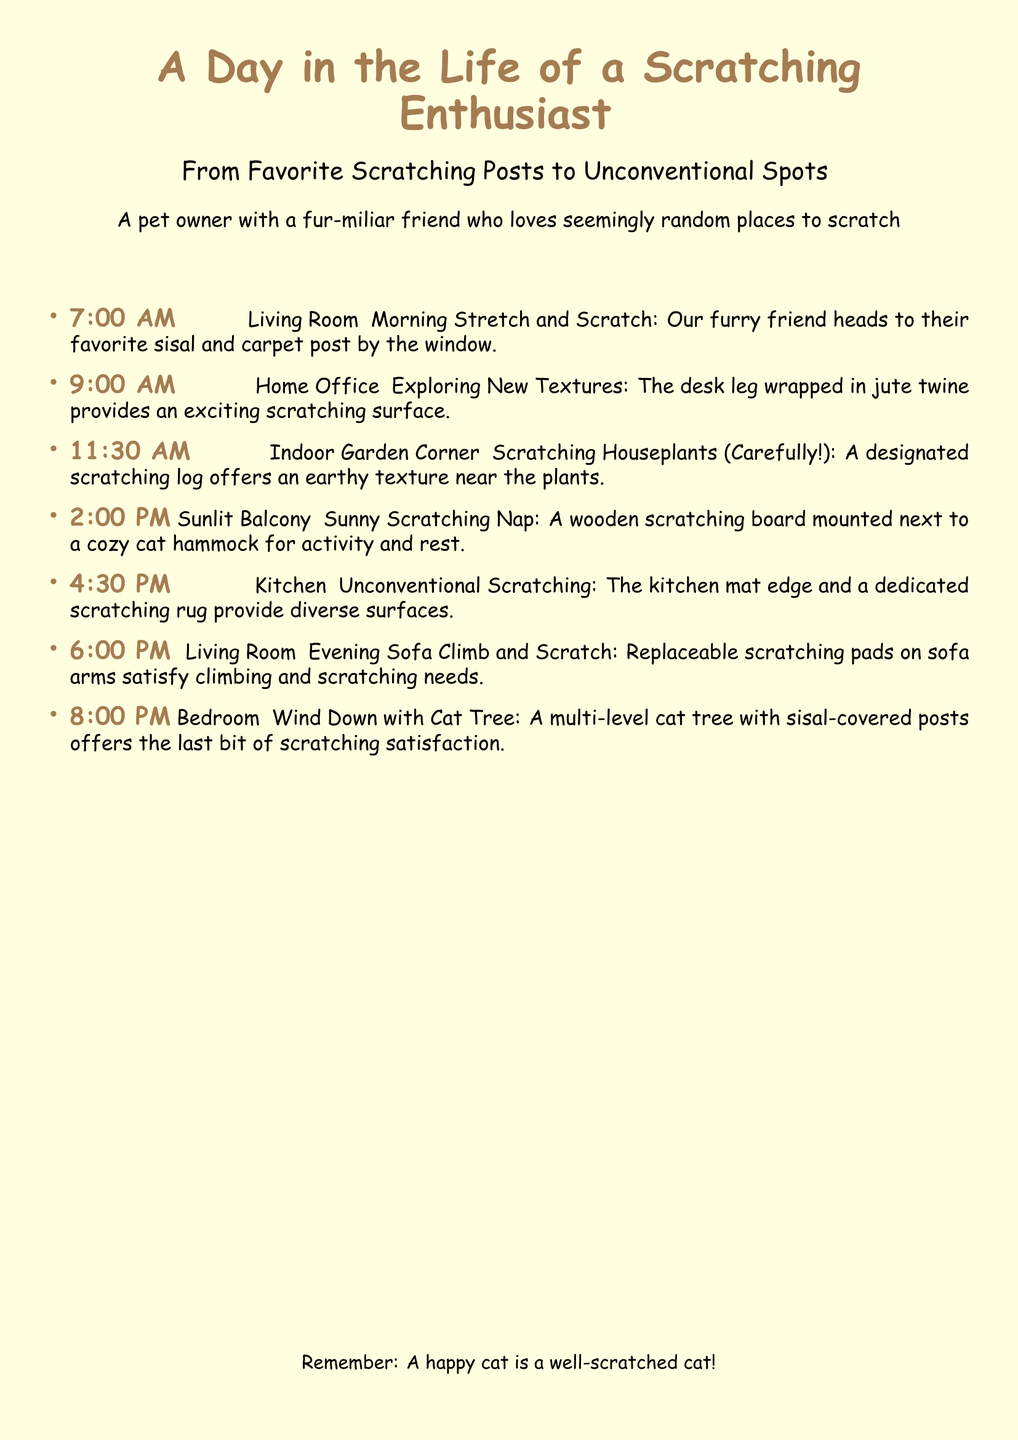What time does the day start? The day starts at 7:00 AM, as indicated by the first time entry in the itinerary.
Answer: 7:00 AM Where does the cat scratch at 9:00 AM? The cat scratches at the home office, specifically on the desk leg wrapped in jute twine.
Answer: Home Office What is the last scratching location mentioned? The last scratching location mentioned is the bedroom with the cat tree.
Answer: Bedroom How many unconventional scratching spots are listed? There are two unconventional scratching spots listed: the kitchen mat edge and the dedicated scratching rug.
Answer: Two What type of scratching post is mentioned for the early morning? The early morning scratching post is described as a sisal and carpet post.
Answer: Sisal and carpet post At what time does the cat have a sunny scratching nap? The cat has a sunny scratching nap at 2:00 PM.
Answer: 2:00 PM What texture does the scratching log provide? The scratching log provides an earthy texture.
Answer: Earthy texture What is the purpose of the replaceable scratching pads? The replaceable scratching pads satisfy climbing and scratching needs on the sofa arms.
Answer: Climbing and scratching needs 